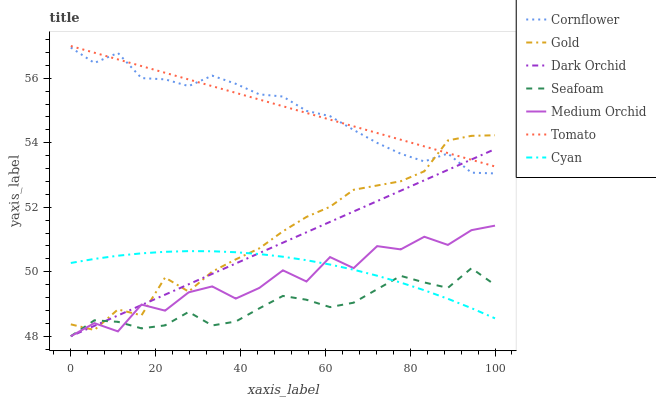Does Seafoam have the minimum area under the curve?
Answer yes or no. Yes. Does Tomato have the maximum area under the curve?
Answer yes or no. Yes. Does Cornflower have the minimum area under the curve?
Answer yes or no. No. Does Cornflower have the maximum area under the curve?
Answer yes or no. No. Is Dark Orchid the smoothest?
Answer yes or no. Yes. Is Medium Orchid the roughest?
Answer yes or no. Yes. Is Cornflower the smoothest?
Answer yes or no. No. Is Cornflower the roughest?
Answer yes or no. No. Does Medium Orchid have the lowest value?
Answer yes or no. Yes. Does Cornflower have the lowest value?
Answer yes or no. No. Does Tomato have the highest value?
Answer yes or no. Yes. Does Cornflower have the highest value?
Answer yes or no. No. Is Seafoam less than Cornflower?
Answer yes or no. Yes. Is Tomato greater than Cyan?
Answer yes or no. Yes. Does Gold intersect Tomato?
Answer yes or no. Yes. Is Gold less than Tomato?
Answer yes or no. No. Is Gold greater than Tomato?
Answer yes or no. No. Does Seafoam intersect Cornflower?
Answer yes or no. No. 